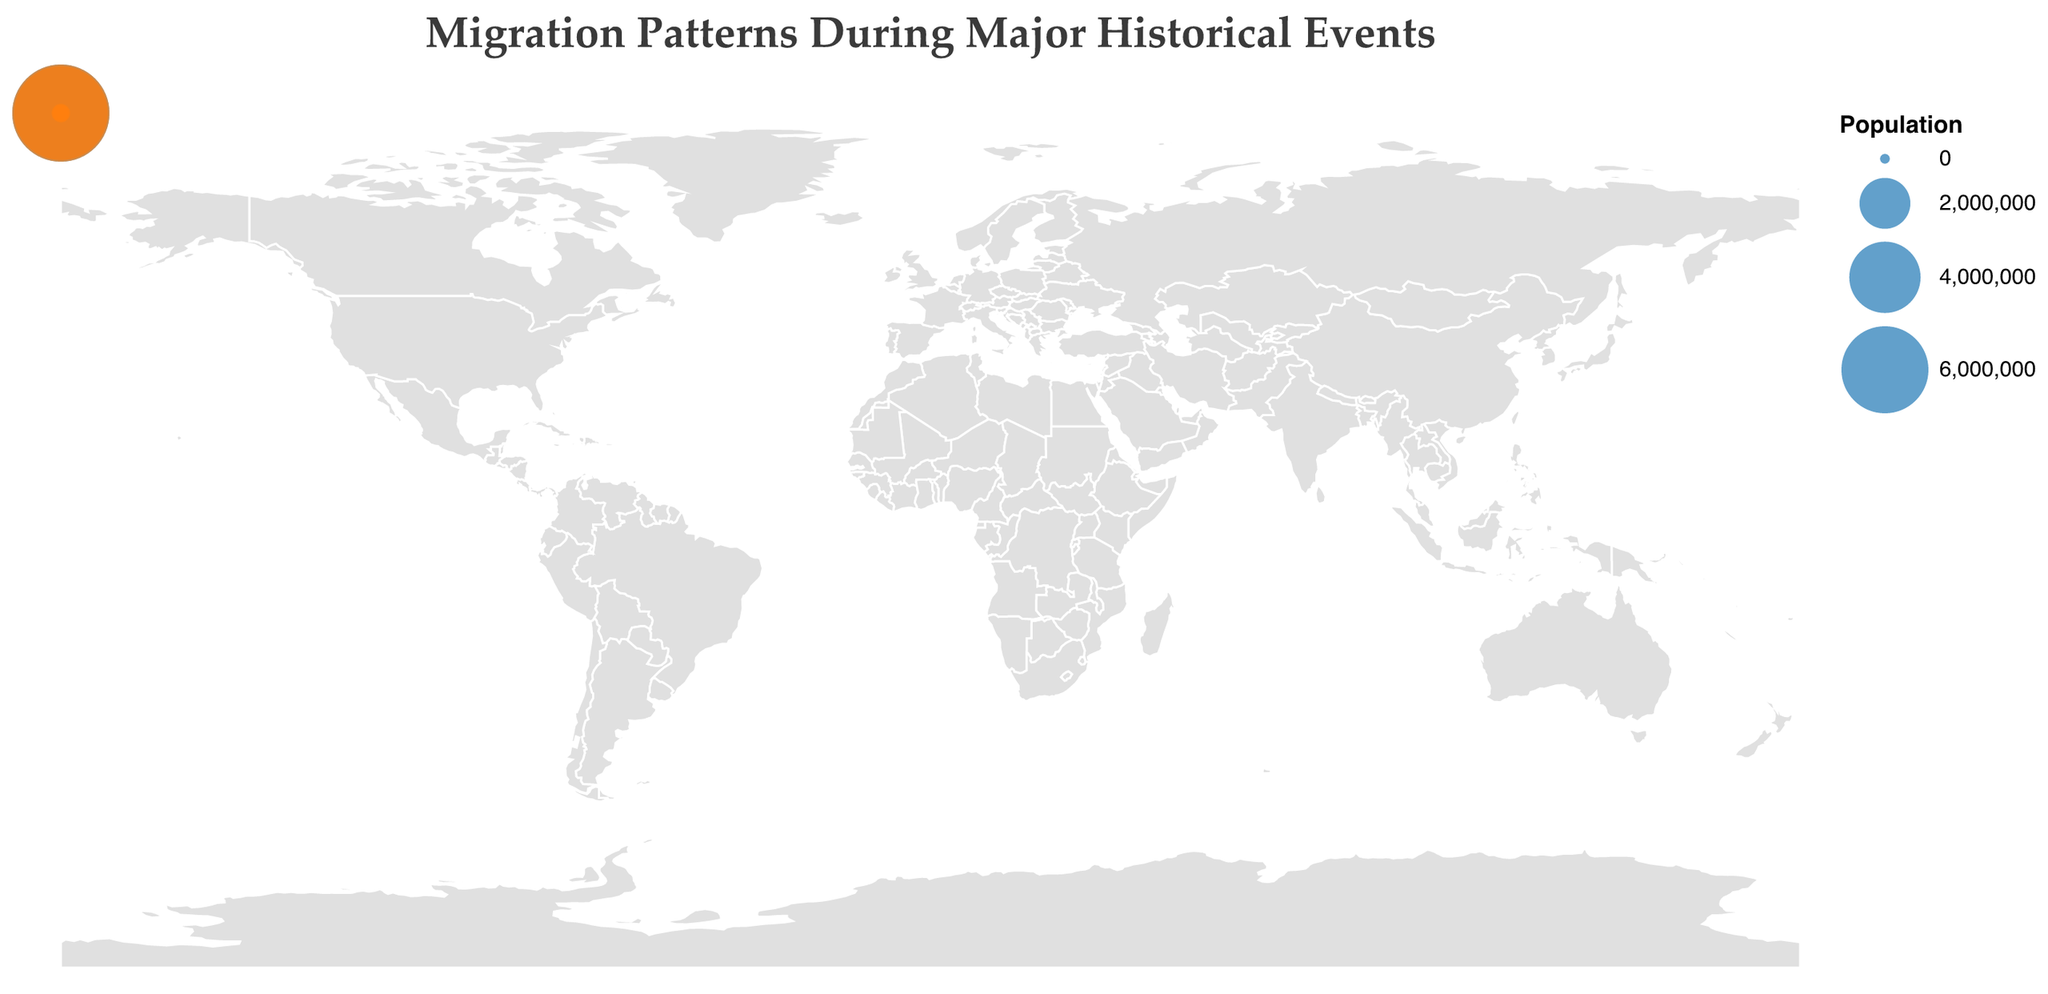What is the title of the figure? The title is displayed at the top of the figure. It reads "Migration Patterns During Major Historical Events".
Answer: Migration Patterns During Major Historical Events Which event caused the largest migration in terms of population? To find the largest migration, you need to look at the size of the circles, particularly comparing the largest ones. The Partition of India events have the largest bubbles, with populations of 7,000,000 and 7,500,000.
Answer: Partition of India How many events are listed in the year 1846? Count the data points for the year 1846, which are associated with the "Irish Potato Famine". There are two data points.
Answer: Two What is the destination with the highest number of migrants during the Dust Bowl? Check the year 1930 and look at the data related to the Dust Bowl. There are two origins, Oklahoma and Texas, both with destinations to California. The populations are 200,000 and 150,000, respectively, making California the destination with the highest number of migrants.
Answer: California Which migration event from Russia has the highest population? To determine this, find the migrations originating from Russia. The 1918 Russian Civil War has migrations to France and Germany. The population to France is larger, with 25,000 compared to 20,000 to Germany.
Answer: Russian Civil War to France Which historical event led to migration to multiple destinations within the same year? Identify events where the same year has multiple destinations. The Great Chicago Fire in 1871 led to migrations to both Milwaukee and St. Louis.
Answer: Great Chicago Fire What is the combined population migrant from Ireland during the Irish Potato Famine? The populations migrating from Ireland in 1846 are 100,000 to the United States and 50,000 to England. Summing these gives 100,000 + 50,000 = 150,000.
Answer: 150,000 Which event leads to the largest migration to the United States? Look for events with the destination being the United States. The year 1939, related to World War II, has a migration from Germany to the United States with a population of 100,000.
Answer: World War II What is the average population size of the migration events depicted in the figure? Add up all the populations and divide by the number of events: (100,000 + 50,000 + 80,000 + 40,000 + 30,000 + 50,000 + 25,000 + 20,000 + 200,000 + 150,000 + 100,000 + 80,000 + 7,000,000 + 7,500,000) / 14 = 1,156,428.57.
Answer: 1,156,428.57 